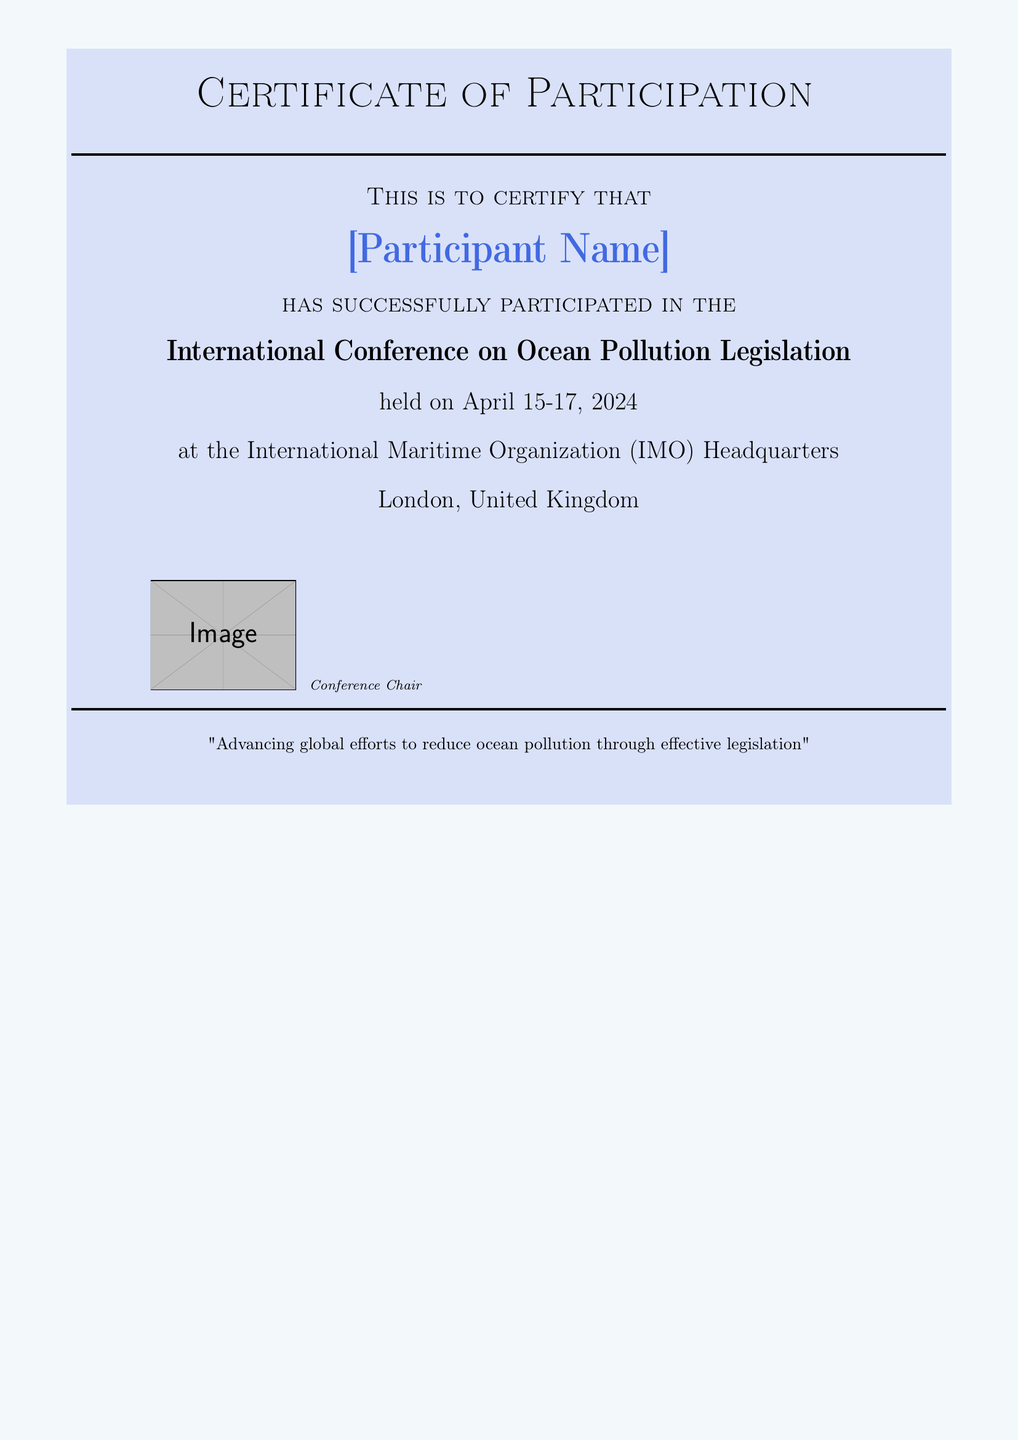What is the title of the event? The title of the event is mentioned clearly in the document as "International Conference on Ocean Pollution Legislation."
Answer: International Conference on Ocean Pollution Legislation When is the conference taking place? The specific dates of the conference are stated in the document as "April 15-17, 2024."
Answer: April 15-17, 2024 Where is the conference being held? The location of the conference is detailed in the document as "International Maritime Organization (IMO) Headquarters, London, United Kingdom."
Answer: International Maritime Organization (IMO) Headquarters Who will sign the certificate? The document indicates that the certificate will be signed by the "Conference Chair."
Answer: Conference Chair What is the theme of the conference? The document provides a quote about the theme of the conference, which emphasizes global efforts related to ocean pollution.
Answer: "Advancing global efforts to reduce ocean pollution through effective legislation" What type of document is this? The nature of the document is identified in its title as a "Certificate of Participation."
Answer: Certificate of Participation How is the participant's name displayed? The participant's name is highlighted and formatted in large text within the document, represented as "[Participant Name]."
Answer: [Participant Name] What color is the background of the document? The background color of the document is described in the formatting as "lightblue."
Answer: lightblue How many columns are used for the images and signatures? There are two columns utilized in the document layout for the images and signatures.
Answer: 2 